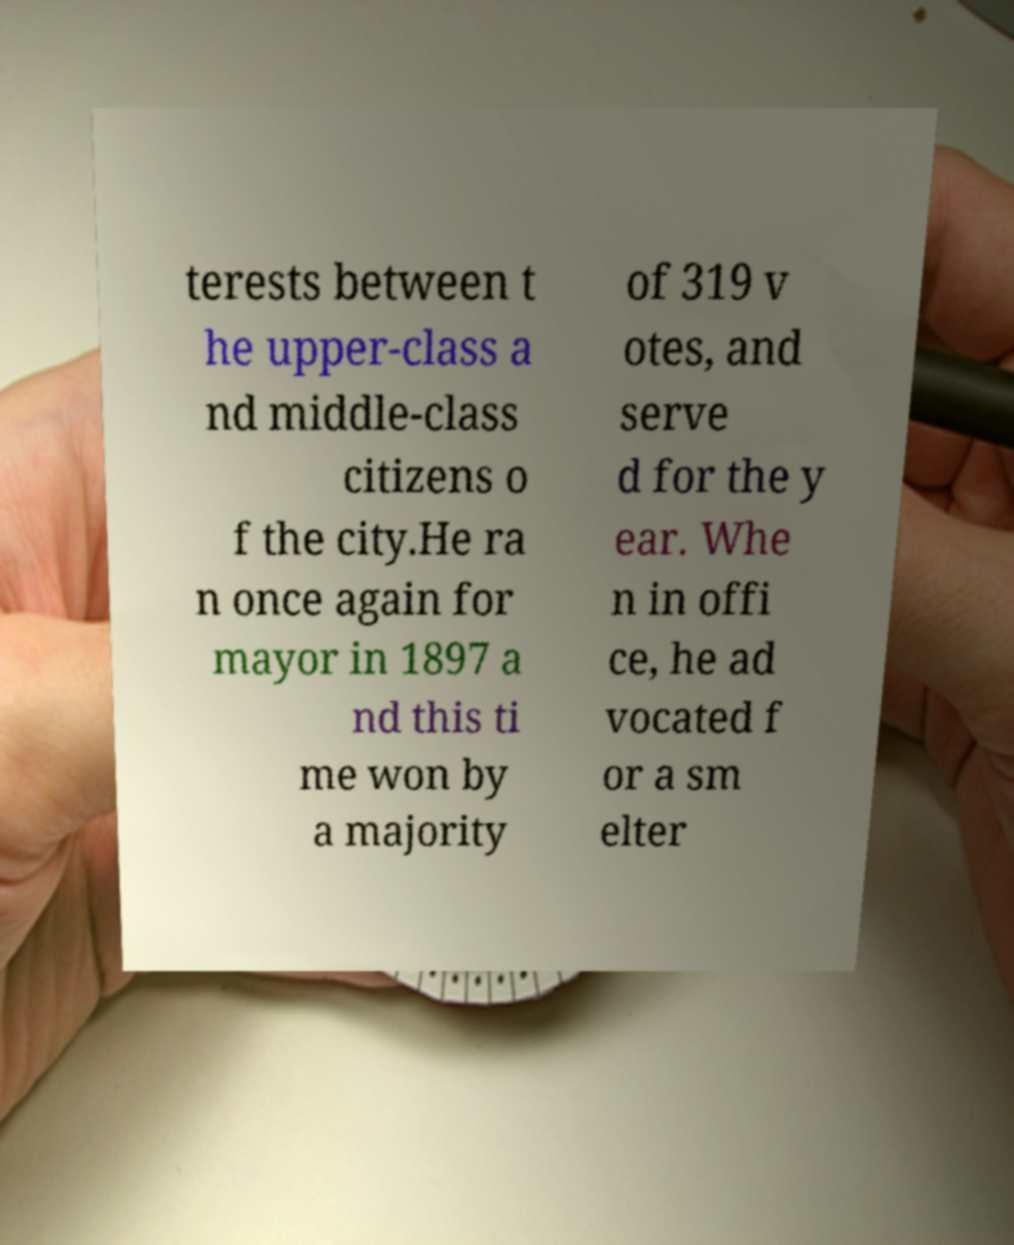For documentation purposes, I need the text within this image transcribed. Could you provide that? terests between t he upper-class a nd middle-class citizens o f the city.He ra n once again for mayor in 1897 a nd this ti me won by a majority of 319 v otes, and serve d for the y ear. Whe n in offi ce, he ad vocated f or a sm elter 